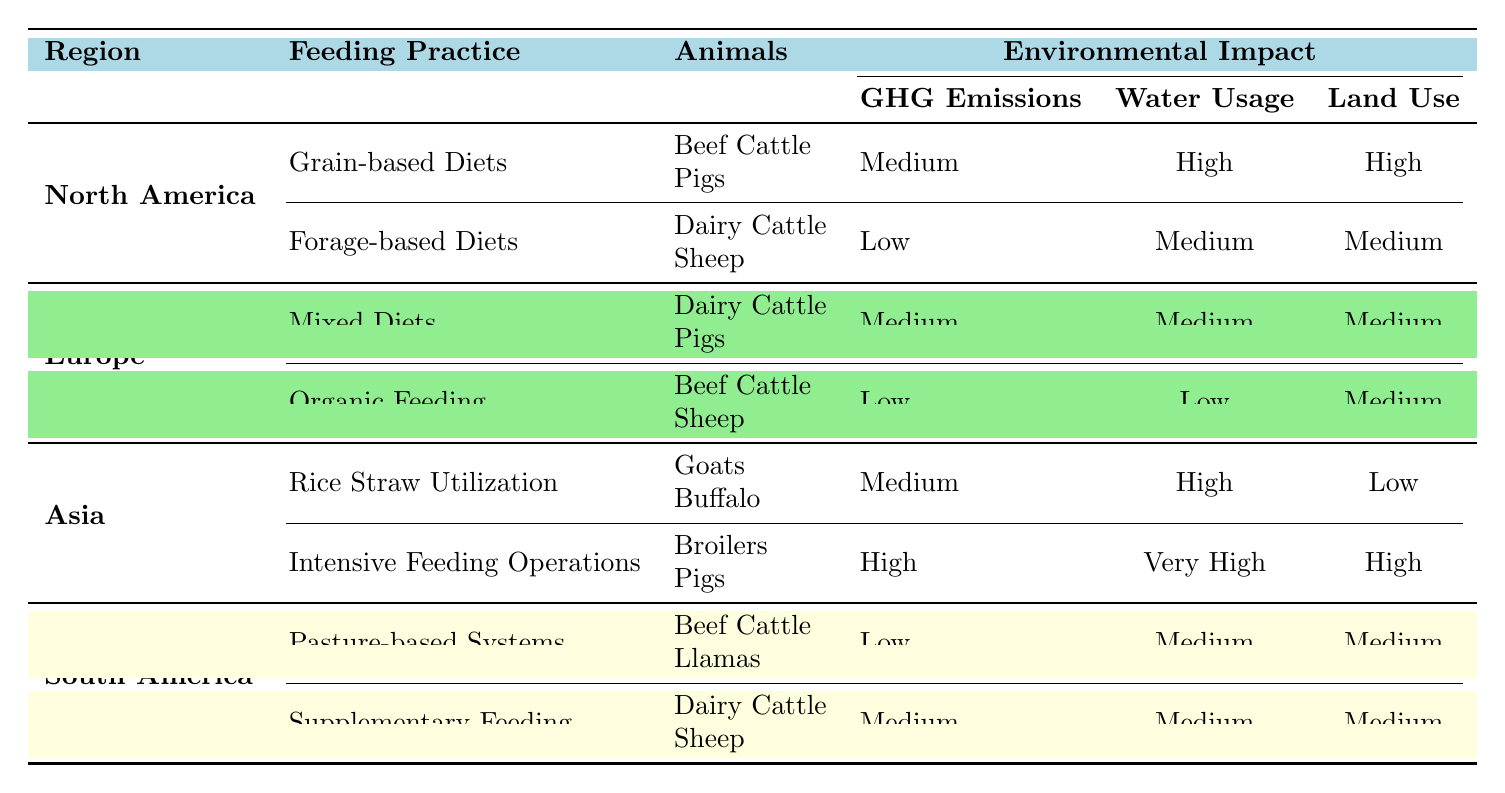What are the environmental impacts associated with Grain-based Diets in North America? Grain-based Diets, used for Beef Cattle and Pigs in North America, have environmental impacts of Medium Greenhouse Gas Emissions, High Water Usage, and High Land Use.
Answer: Medium greenhouse gas emissions, high water usage, high land use Which region has the lowest greenhouse gas emissions from livestock feeding practices? The region with the lowest greenhouse gas emissions is South America, specifically for Pasture-based Systems, which have Low emissions.
Answer: South America How many animals are associated with the Intensive Feeding Operations in Asia? Intensive Feeding Operations in Asia involve two animals: Broilers and Pigs.
Answer: Two animals Is it true that Organic Feeding in Europe has low water usage? Yes, Organic Feeding in Europe results in Low water usage, as indicated in the table.
Answer: Yes What is the difference in land use between Forage-based Diets and Organic Feeding? Forage-based Diets have Medium land use, while Organic Feeding has Medium land use as well. Therefore, the difference is 0.
Answer: 0 